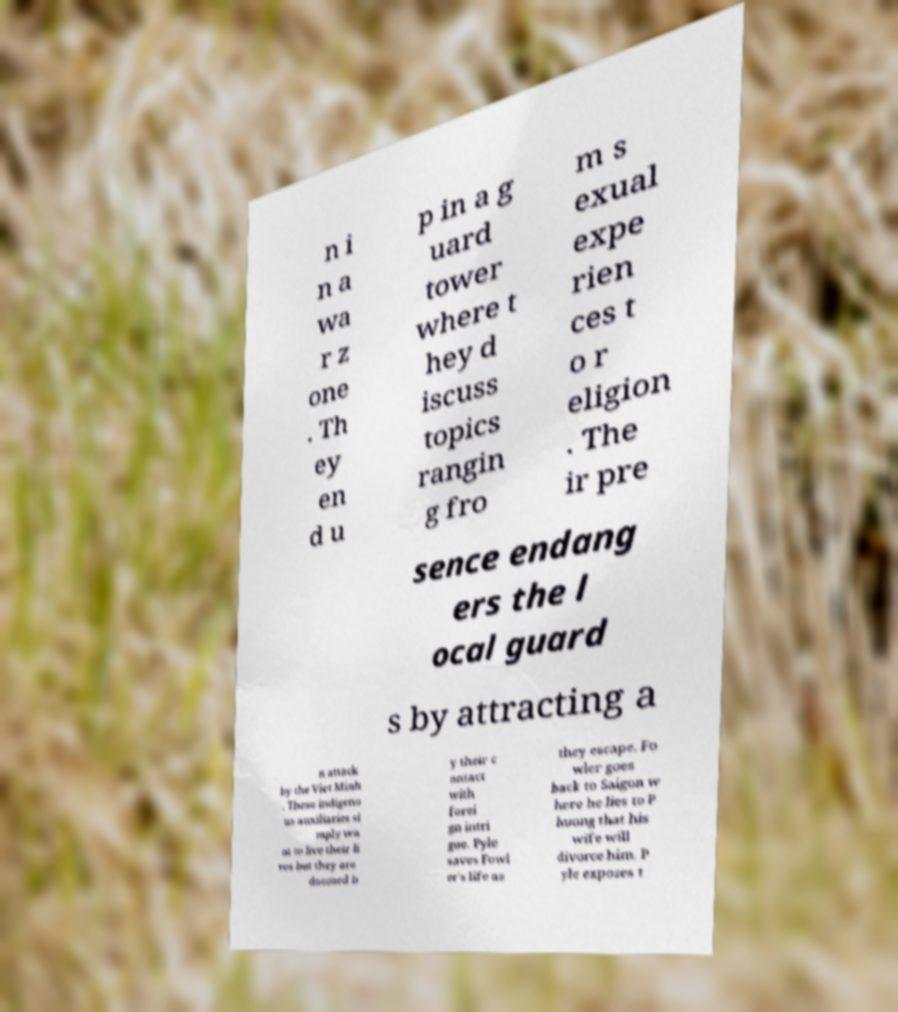Could you extract and type out the text from this image? n i n a wa r z one . Th ey en d u p in a g uard tower where t hey d iscuss topics rangin g fro m s exual expe rien ces t o r eligion . The ir pre sence endang ers the l ocal guard s by attracting a n attack by the Viet Minh . These indigeno us auxiliaries si mply wa nt to live their li ves but they are doomed b y their c ontact with forei gn intri gue. Pyle saves Fowl er's life as they escape. Fo wler goes back to Saigon w here he lies to P huong that his wife will divorce him. P yle exposes t 